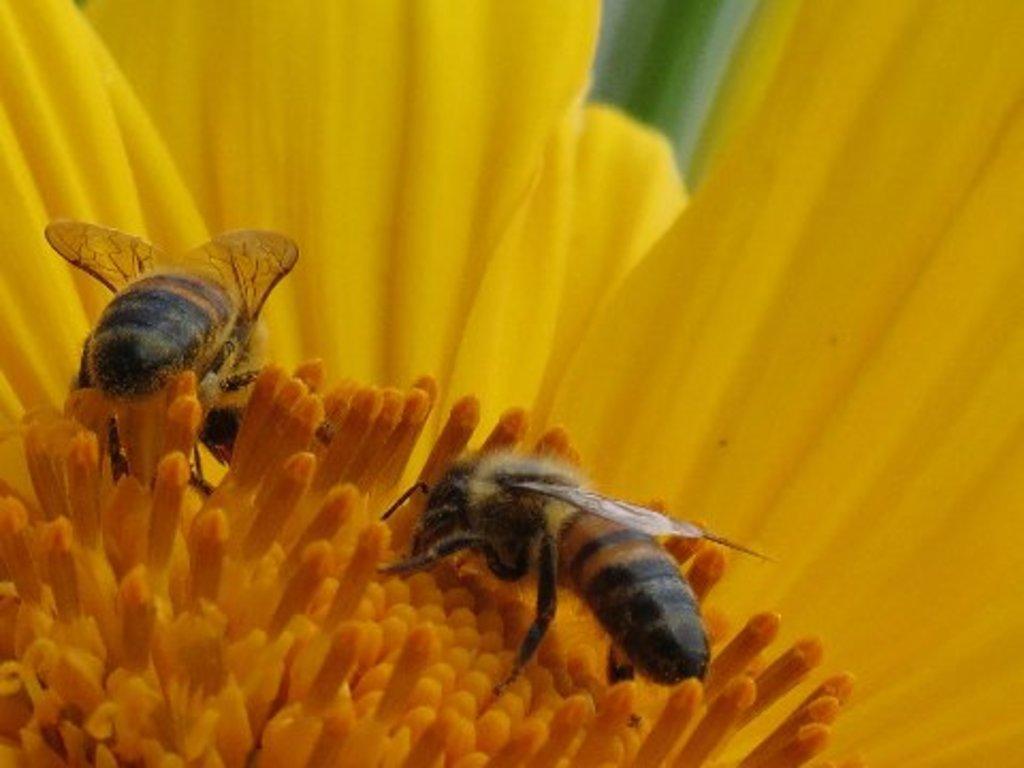Please provide a concise description of this image. Here we can see bees on yellow flower. 